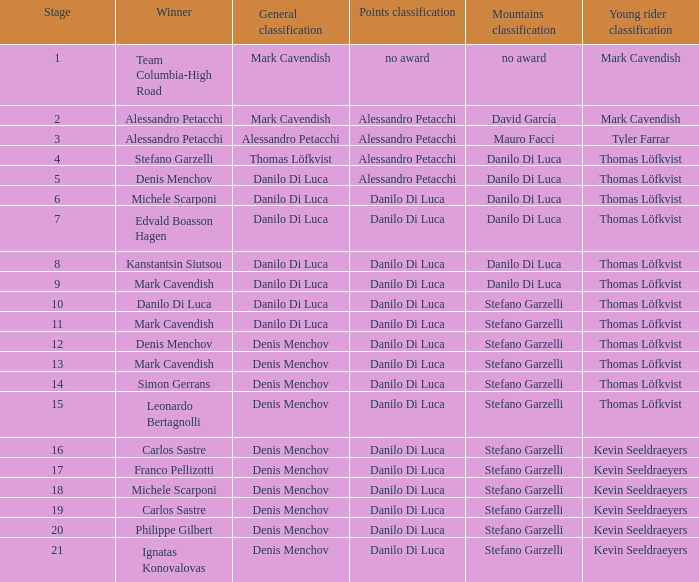When danilo di luca is the winner who is the general classification?  Danilo Di Luca. 